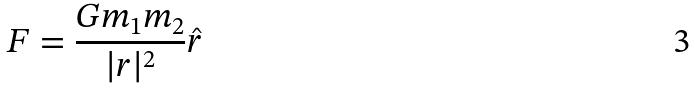<formula> <loc_0><loc_0><loc_500><loc_500>F = \frac { G m _ { 1 } m _ { 2 } } { | r | ^ { 2 } } \hat { r }</formula> 